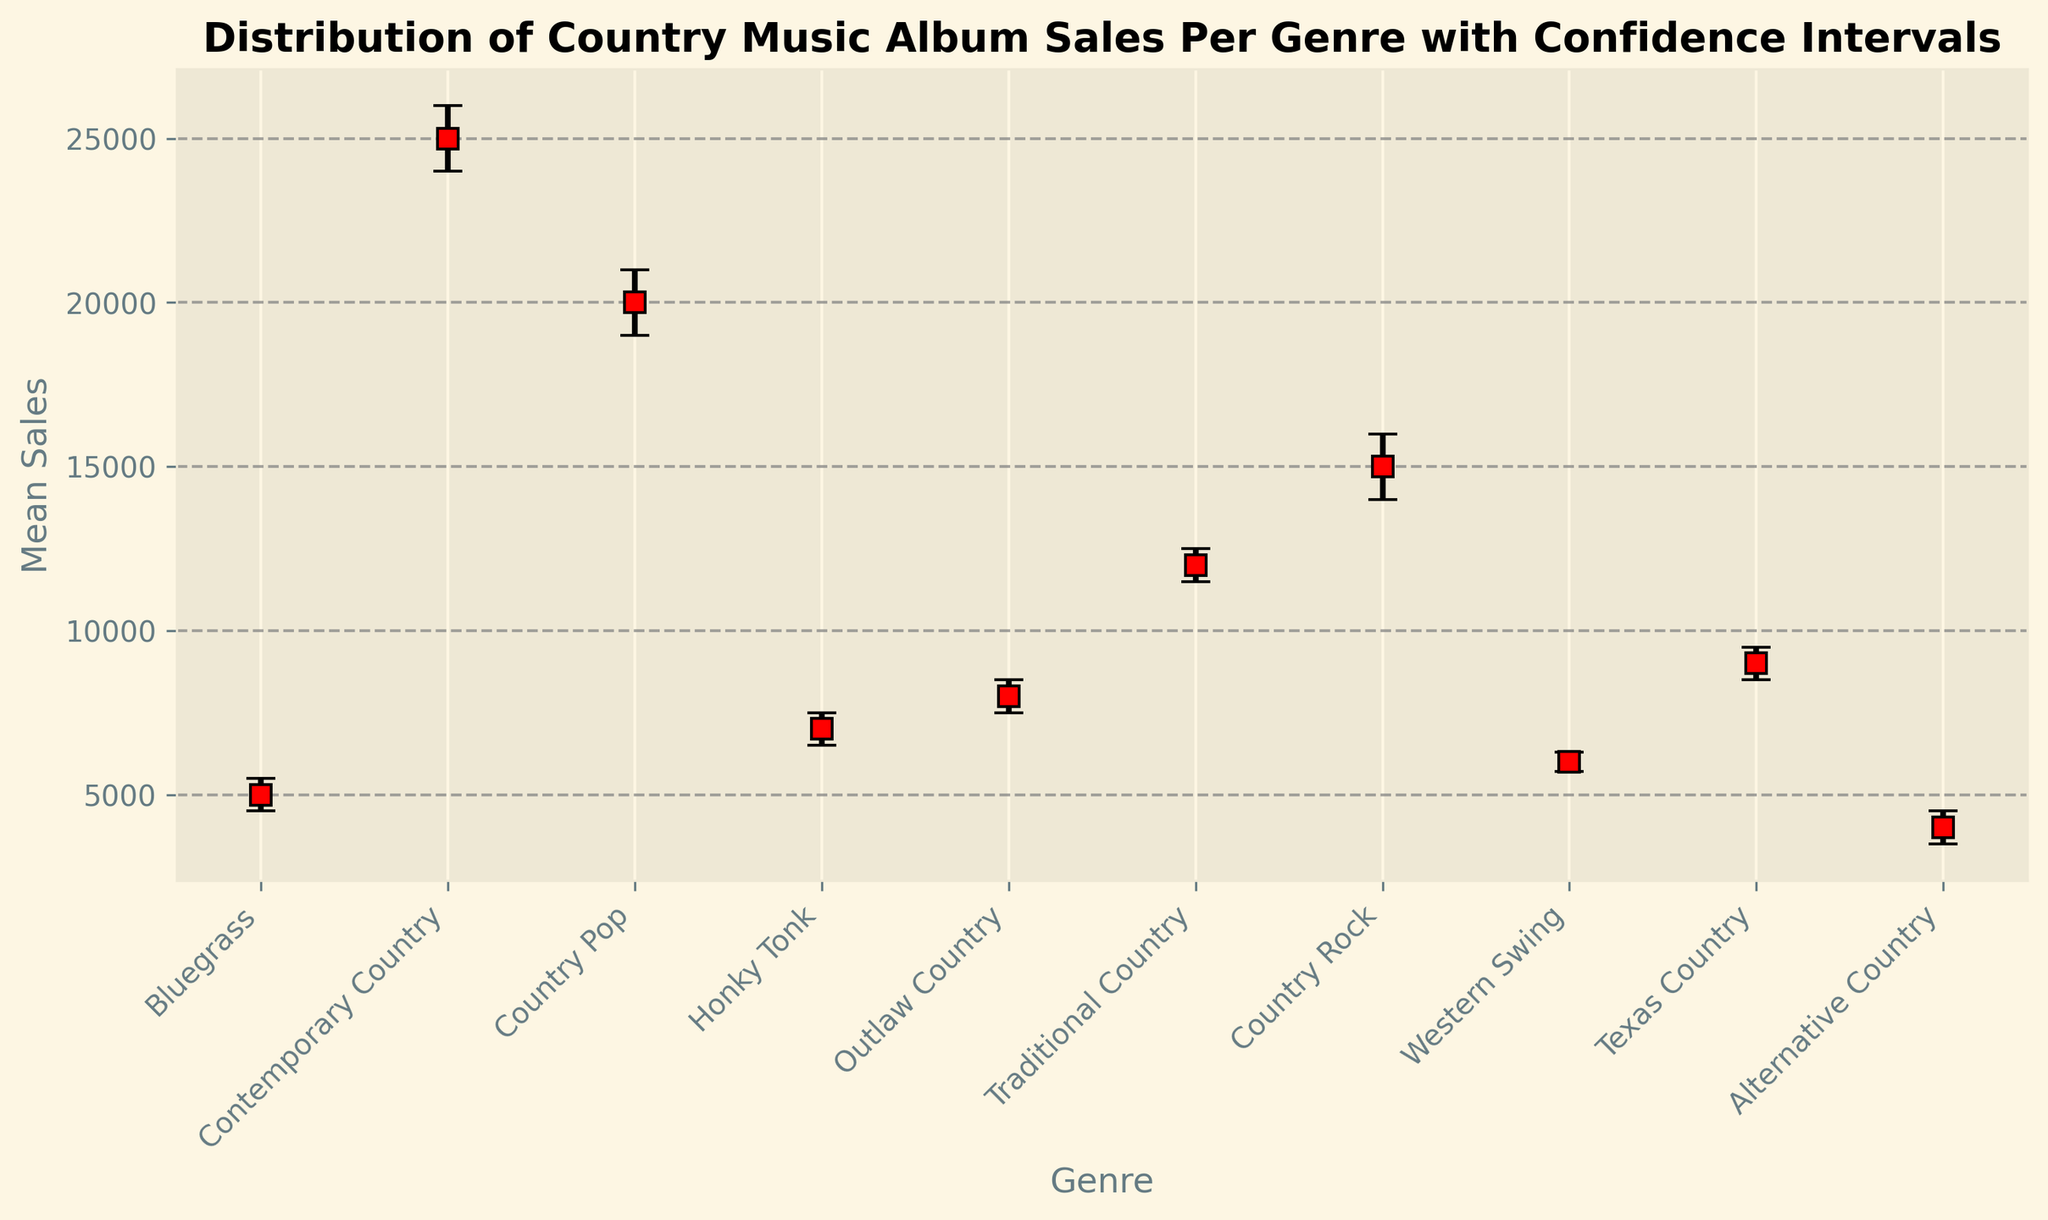what's the genre with the highest mean sales? By looking at the chart, identify the genre which has the highest mean sales value. The bar for Contemporary Country is the highest.
Answer: Contemporary Country Which genre has the lowest mean sales? Identify the genre with the smallest mean sales value by examining the chart. Alternative Country has the lowest value.
Answer: Alternative Country What is the difference in mean sales between Country Rock and Honky Tonk? Calculate the difference between the mean sales value of Country Rock (15000) and Honky Tonk (7000).
Answer: 8000 How much higher are the upper confidence intervals for Country Pop compared to Bluegrass? Look at the upper confidence interval for Country Pop (21000) and Bluegrass (5500) and calculate the difference.
Answer: 15500 What’s the combined mean sales for Bluegrass, Outlaw Country, and Texas Country? Add the mean sales values for Bluegrass (5000), Outlaw Country (8000), and Texas Country (9000).
Answer: 22000 Which genre has the widest confidence interval? Identify the genre with the largest span between the lower and upper confidence interval. Contemporary Country has the widest range (2000).
Answer: Contemporary Country Which two genres have the closest mean sales values? Compare the mean sales values and find the two that are closest together. Traditional Country (12000) and Country Rock (15000) are closest.
Answer: Traditional Country and Country Rock Which genre shows the smallest range of error bars? Identify the genre with the smallest span between its lower and upper confidence intervals. Bluegrass has the smallest range (1000).
Answer: Bluegrass 